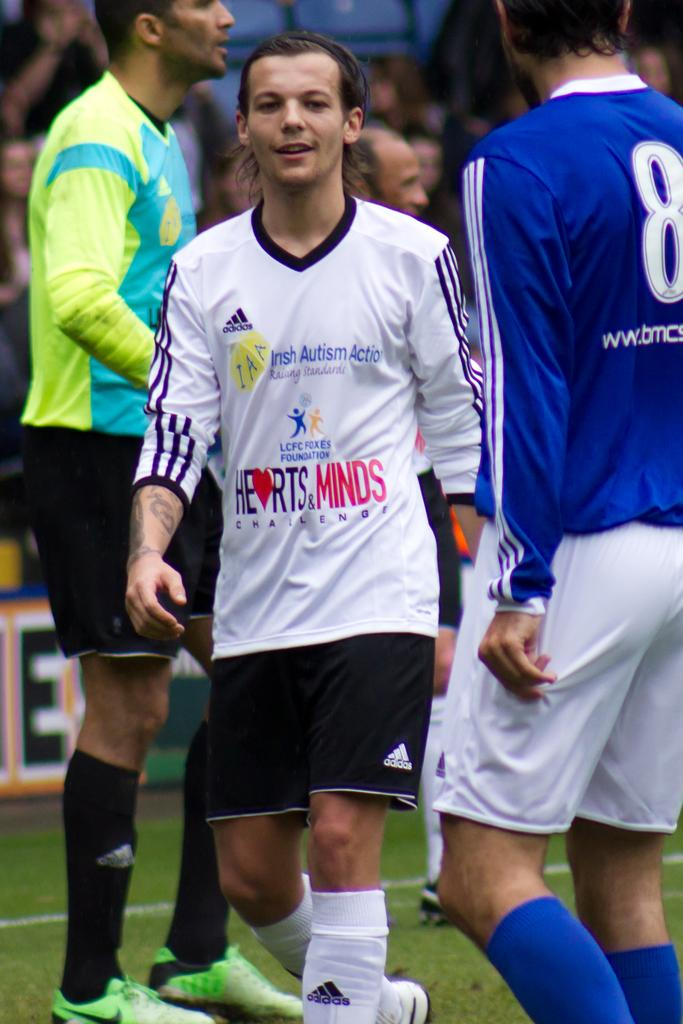<image>
Summarize the visual content of the image. Soccer players wearing different jerseys, including one for Irish Autism Acton. 